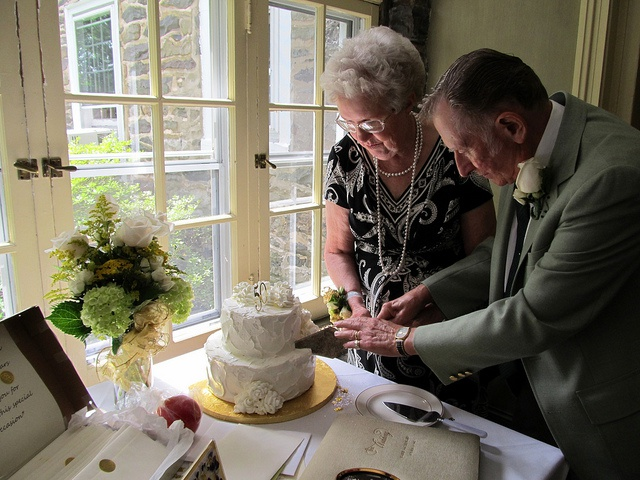Describe the objects in this image and their specific colors. I can see people in gray, black, and maroon tones, people in gray, black, maroon, and darkgray tones, potted plant in gray, olive, black, and darkgray tones, cake in gray and darkgray tones, and knife in gray and black tones in this image. 